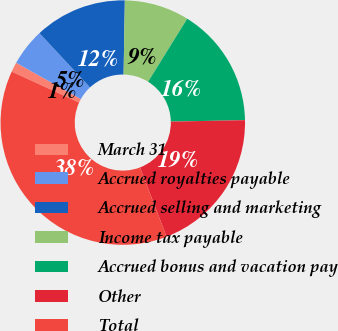Convert chart to OTSL. <chart><loc_0><loc_0><loc_500><loc_500><pie_chart><fcel>March 31<fcel>Accrued royalties payable<fcel>Accrued selling and marketing<fcel>Income tax payable<fcel>Accrued bonus and vacation pay<fcel>Other<fcel>Total<nl><fcel>1.29%<fcel>4.93%<fcel>12.21%<fcel>8.57%<fcel>15.85%<fcel>19.49%<fcel>37.68%<nl></chart> 